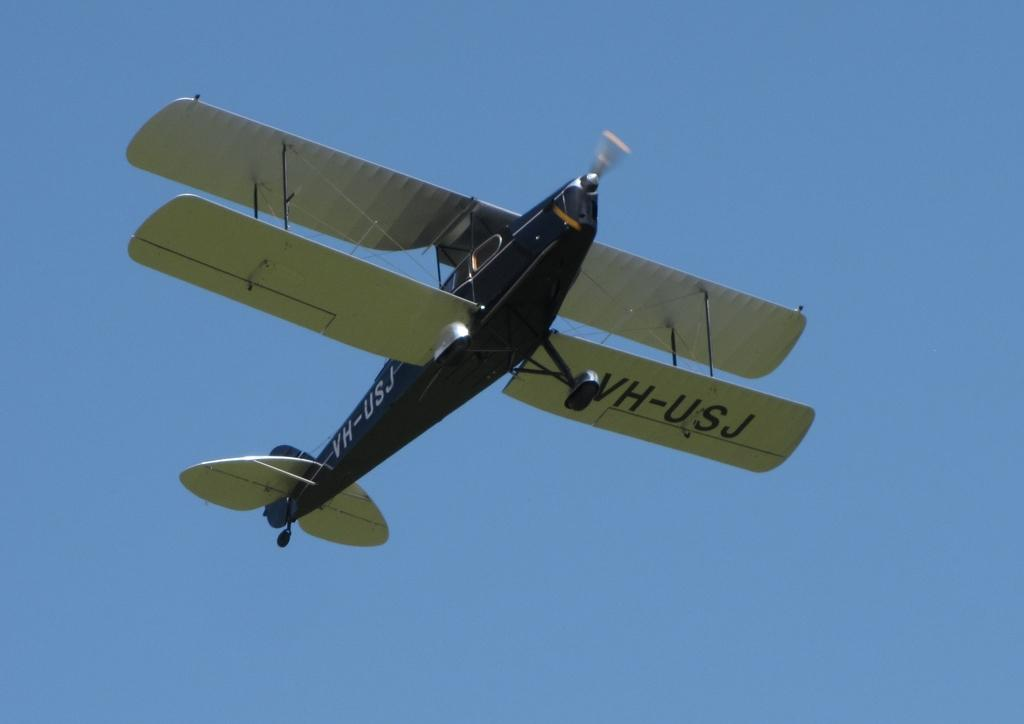What is the main subject of the image? The main subject of the image is an aircraft. What is the aircraft doing in the image? The aircraft is flying. What can be seen in the background of the image? The sky is visible in the background of the image. What type of underwear is the aircraft wearing in the image? Aircraft do not wear underwear, as they are inanimate objects and not living beings. Can you tell me how many cameras are visible in the image? There is no camera present in the image; it features an aircraft flying in the sky. 